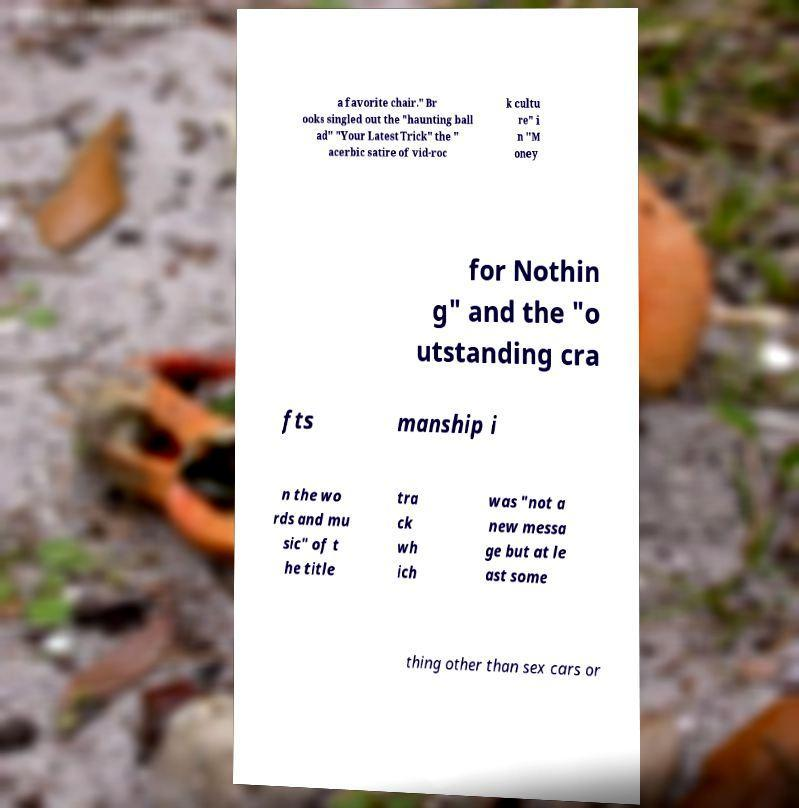Please identify and transcribe the text found in this image. a favorite chair." Br ooks singled out the "haunting ball ad" "Your Latest Trick" the " acerbic satire of vid-roc k cultu re" i n "M oney for Nothin g" and the "o utstanding cra fts manship i n the wo rds and mu sic" of t he title tra ck wh ich was "not a new messa ge but at le ast some thing other than sex cars or 